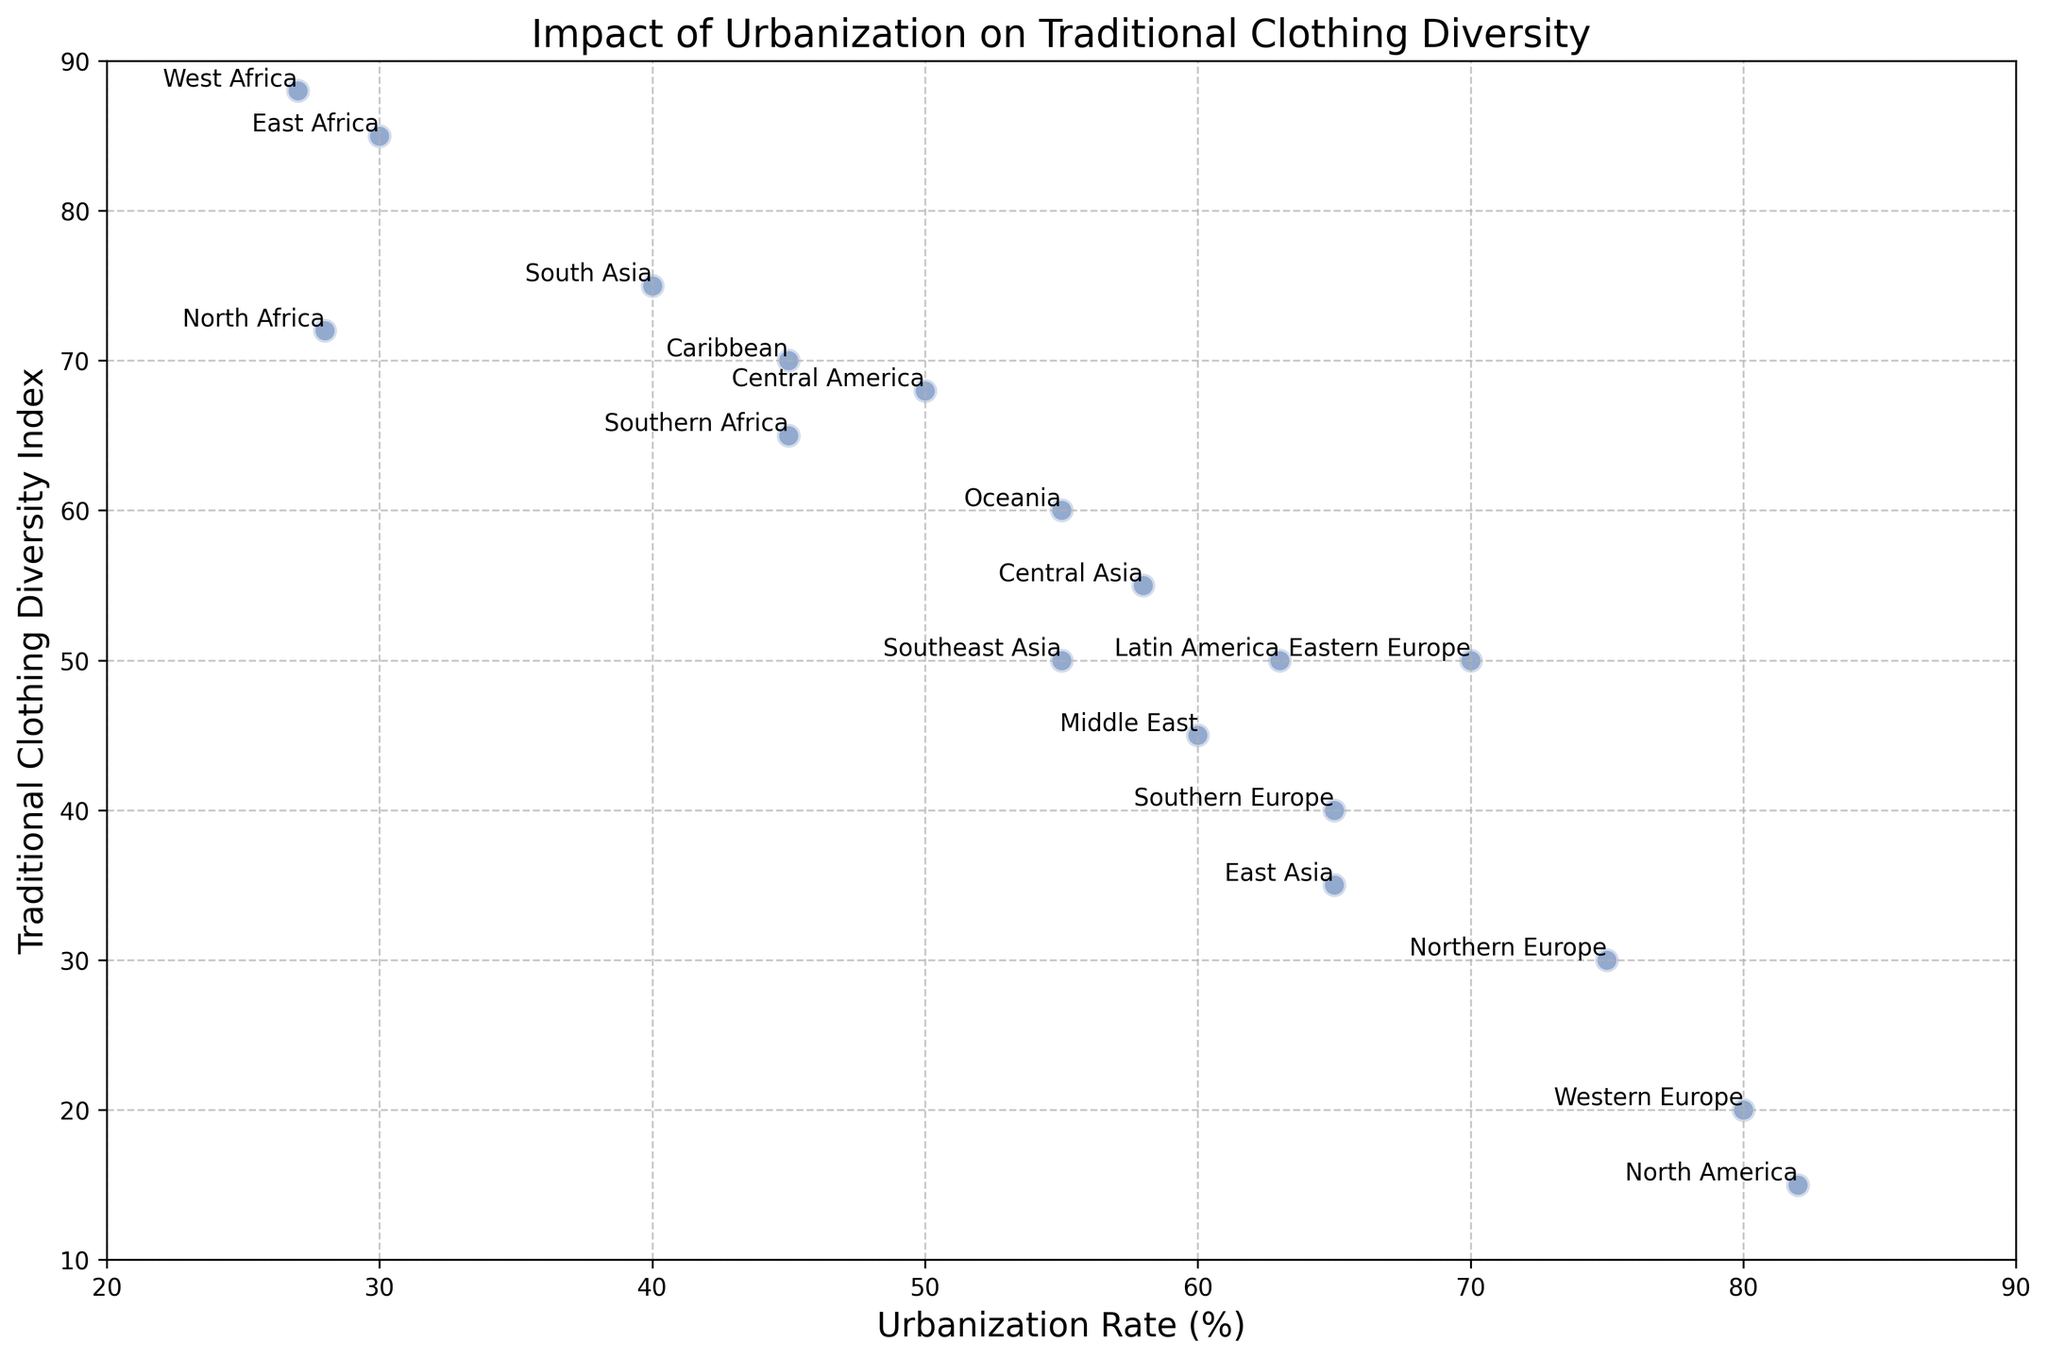Which region has the highest traditional clothing diversity index? To determine the region with the highest traditional clothing diversity index, we look for the highest point on the vertical axis. The point with the highest value for Traditional Clothing Diversity Index is in West Africa with a value of 88.
Answer: West Africa Which region has the lowest traditional clothing diversity index? To find the region with the lowest traditional clothing diversity index, we locate the point with the lowest value on the vertical axis. The point with the lowest Traditional Clothing Diversity Index is for North America with a value of 15.
Answer: North America What is the average traditional clothing diversity index for regions with an urbanization rate of at least 60%? We identify the regions with an urbanization rate of at least 60%: East Asia (35), Middle East (45), Eastern Europe (50), Western Europe (20), Northern Europe (30), Southern Europe (40), North America (15), and Latin America (50). Summing these values gives 35 + 45 + 50 + 20 + 30 + 40 + 15 + 50 = 285. There are 8 regions, so the average is 285 / 8 = 35.625.
Answer: 35.625 Which region has a higher urbanization rate, Southern Europe, or Southern Africa? To compare the urbanization rates of Southern Europe and Southern Africa, we locate their points along the horizontal axis. Southern Europe has an urbanization rate of 65%, while Southern Africa has an urbanization rate of 45%. 65 is greater than 45, so Southern Europe has a higher urbanization rate.
Answer: Southern Europe Is the traditional clothing diversity index for East Asia higher or lower than that of Southeast Asia? To compare the traditional clothing diversity indexes of East Asia and Southeast Asia, we locate their points on the vertical axis. East Asia has a diversity index of 35, while Southeast Asia has a diversity index of 50. 35 is less than 50, so East Asia has a lower traditional clothing diversity index.
Answer: Lower What is the relationship between the urbanization rate and the traditional clothing diversity index? By observing the scatter plot, we can see that as the urbanization rate increases, the traditional clothing diversity index generally decreases, indicating a negative correlation.
Answer: Negative correlation Calculate the difference in traditional clothing diversity index between Central America and North Africa. To calculate the difference, we take the diversity index of Central America and North Africa. Central America has 68, and North Africa has 72. So, the difference is 72 - 68 = 4.
Answer: 4 Which region has the highest urbanization rate, and what is its traditional clothing diversity index? To find the region with the highest urbanization rate, we look for the point farthest to the right on the horizontal axis. North America has the highest urbanization rate at 82%, and its traditional clothing diversity index is 15.
Answer: North America, 15 